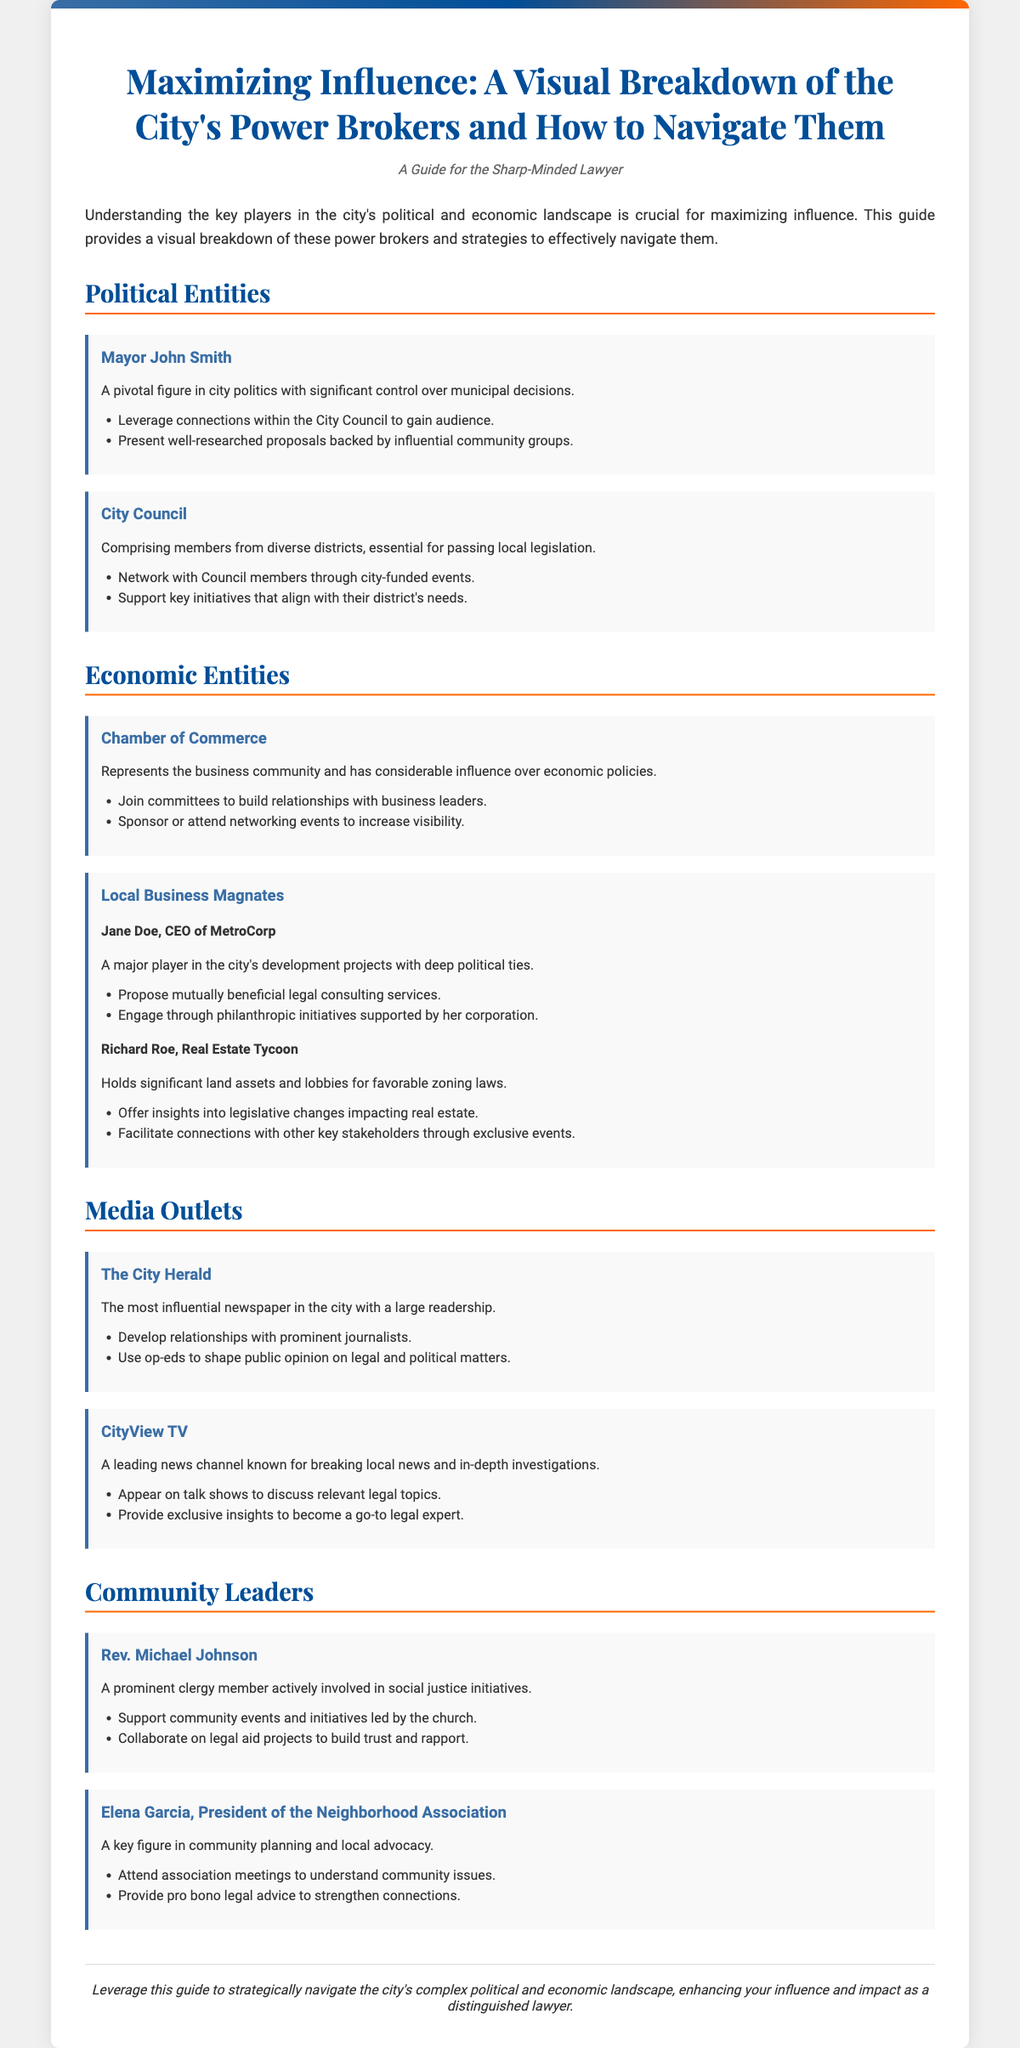What is the title of the poster? The title appears at the top of the document, summarizing the main theme of the content.
Answer: Maximizing Influence: A Visual Breakdown of the City's Power Brokers and How to Navigate Them Who is the Mayor mentioned in the document? The document lists key political figures, including the Mayor, identifying their significant roles.
Answer: John Smith What is the role of the City Council? The document describes the City Council's importance in relation to local legislation, highlighting its members' influence.
Answer: Essential for passing local legislation Name one of the local business magnates mentioned. The document provides examples of influential business leaders impacting the city's economic landscape.
Answer: Jane Doe Which newspaper is described as the most influential in the city? The text identifies significant media outlets and their reach within the community.
Answer: The City Herald What major initiative is Rev. Michael Johnson involved in? The document indicates the community issues addressed by this community leader, highlighting their social focus.
Answer: Social justice initiatives What should be proposed to Jane Doe, CEO of MetroCorp? Strategies for engaging with influential figures are outlined, providing specific approaches for collaboration.
Answer: Mutually beneficial legal consulting services What type of events should be attended to network with City Council members? The document suggests activities that help build connections with local political entities.
Answer: City-funded events What is the profession of Elena Garcia? The document introduces community leaders along with their titles and roles within the local context.
Answer: President of the Neighborhood Association 